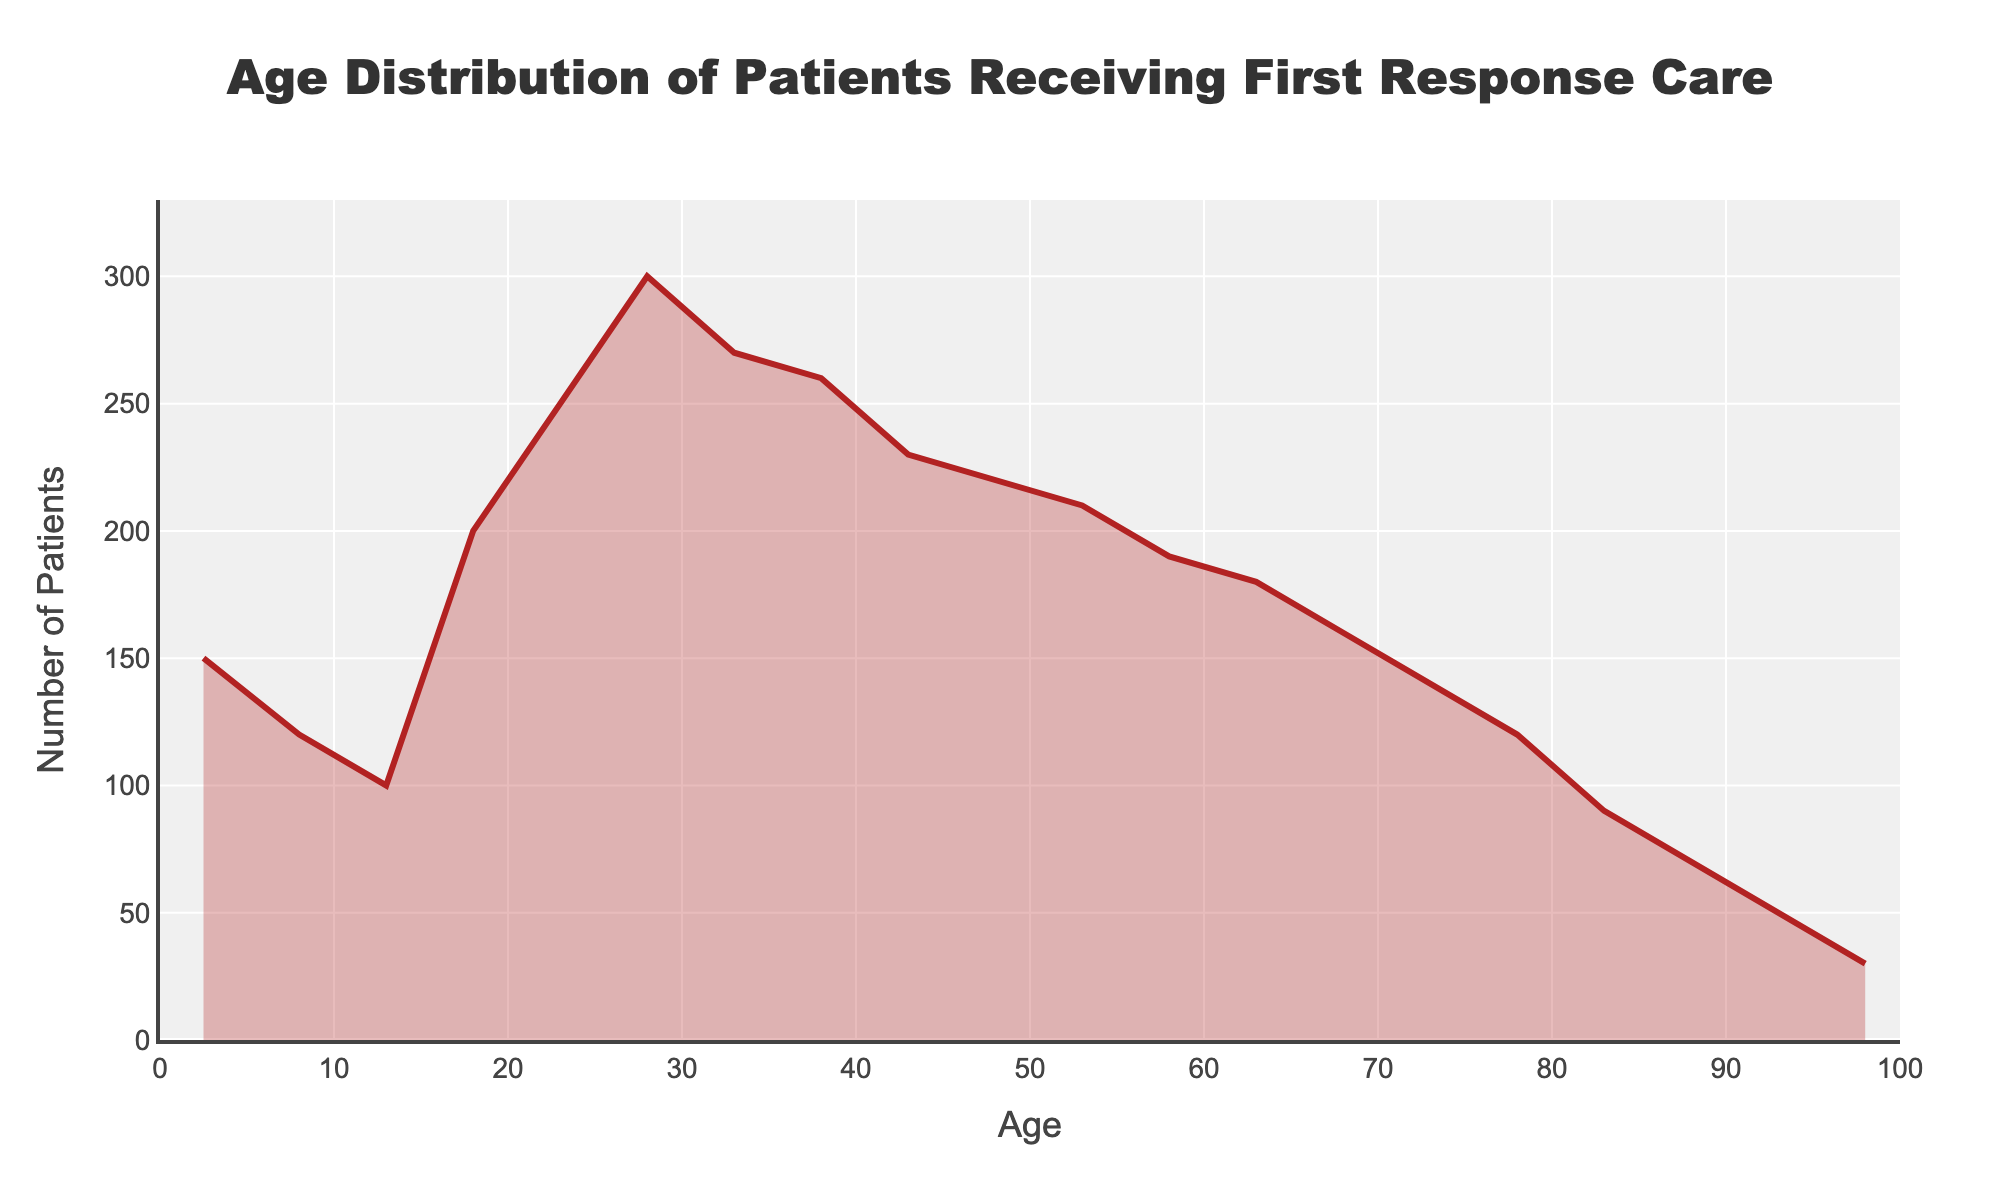What is the title of the plot? The title of the plot appears at the top and reads 'Age Distribution of Patients Receiving First Response Care’.
Answer: Age Distribution of Patients Receiving First Response Care What is the age range that has the maximum number of patients? The age range with the maximum number of patients is indicated by the highest peak in the density plot. This peak is around the 26-30 age range.
Answer: 26-30 How many patients are in the age range 56-60? Look at the plot and find the value on the y-axis corresponding to the age range 56-60. This value is around 190.
Answer: 190 What is the total number of patients between the age of 31-40? Add the number of patients from the age ranges 31-35 and 36-40. According to the plot, these values are 270 and 260, respectively. 270 + 260 = 530.
Answer: 530 Which age range has fewer patients: 81-85 or 91-95? Compare the y-axis values for these age ranges. 81-85 has approximately 90 patients, while 91-95 has about 50 patients.
Answer: 91-95 What is the general trend in the number of patients as age increases from 0 to 100? Observe the density plot from left (age 0) to right (age 100). Initially, the number of patients increases, reaches a peak around age 26-30, and then generally decreases as age increases further.
Answer: Increases then decreases Which age range shows a sudden increase in the number of patients compared to the previous range? Identify points where the plot shows a steep upward slope. The number of patients significantly increases from the 11-15 age range to the 16-20 age range.
Answer: 16-20 How does the number of patients aged 76-80 compare to those aged 96-100? Look at the y-axis values for these age ranges. 76-80 has approximately 120 patients while 96-100 has about 30 patients, indicating the former is higher.
Answer: 76-80 What is the total number of patients in the age groups above 80 years? Sum the patients in the age ranges 81-85, 86-90, 91-95, and 96-100. The quantities are 90, 70, 50, and 30 respectively. 90 + 70 + 50 + 30 = 240.
Answer: 240 